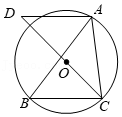First perform reasoning, then finally select the question from the choices in the following format: Answer: xxx.
Question: As shown in the figure, triangle ABC is inscribed in circle O, angle BAC = 50°. AD is drawn parallel to BC passing through point A, and it intersects the extension of CO at point D. The degree of angle D is ().
Choices:
A: 50°
B: 45°
C: 40°
D: 25° As shown in the diagram, connect OB. Since angle BAC = 50°, therefore angle BOC = 2angle BAC = 100°. Hence, angle OCB = (180° - 100°) ÷ 2 = 40°. Since AD is parallel to BC, therefore angle D = angle OCB = 40°. Therefore, the correct answer is C.
Answer:C 